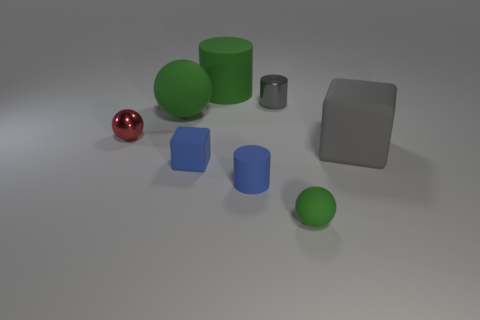Add 1 large matte objects. How many objects exist? 9 Subtract all balls. How many objects are left? 5 Add 6 blue matte blocks. How many blue matte blocks exist? 7 Subtract 0 yellow blocks. How many objects are left? 8 Subtract all big green balls. Subtract all gray matte things. How many objects are left? 6 Add 1 small cylinders. How many small cylinders are left? 3 